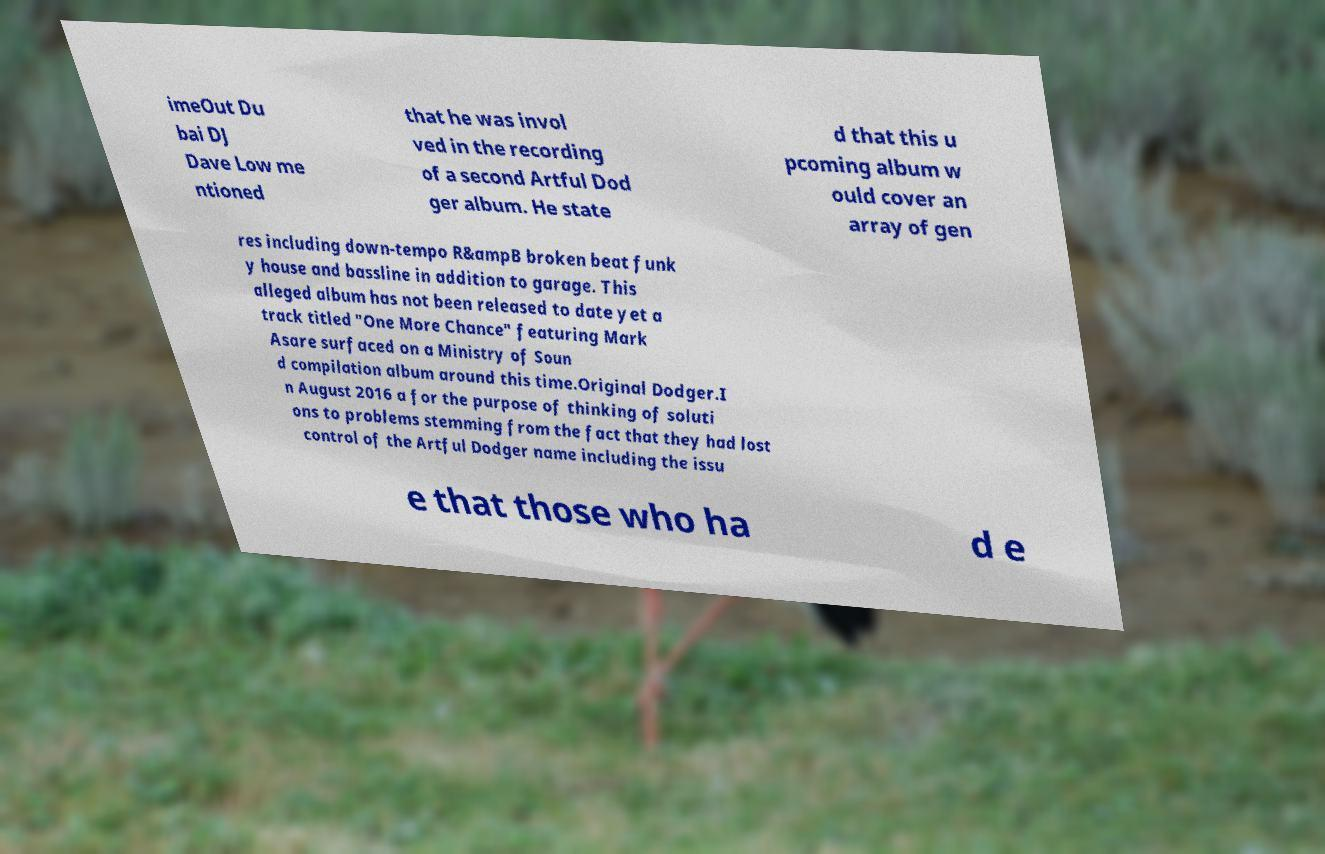I need the written content from this picture converted into text. Can you do that? imeOut Du bai DJ Dave Low me ntioned that he was invol ved in the recording of a second Artful Dod ger album. He state d that this u pcoming album w ould cover an array of gen res including down-tempo R&ampB broken beat funk y house and bassline in addition to garage. This alleged album has not been released to date yet a track titled "One More Chance" featuring Mark Asare surfaced on a Ministry of Soun d compilation album around this time.Original Dodger.I n August 2016 a for the purpose of thinking of soluti ons to problems stemming from the fact that they had lost control of the Artful Dodger name including the issu e that those who ha d e 